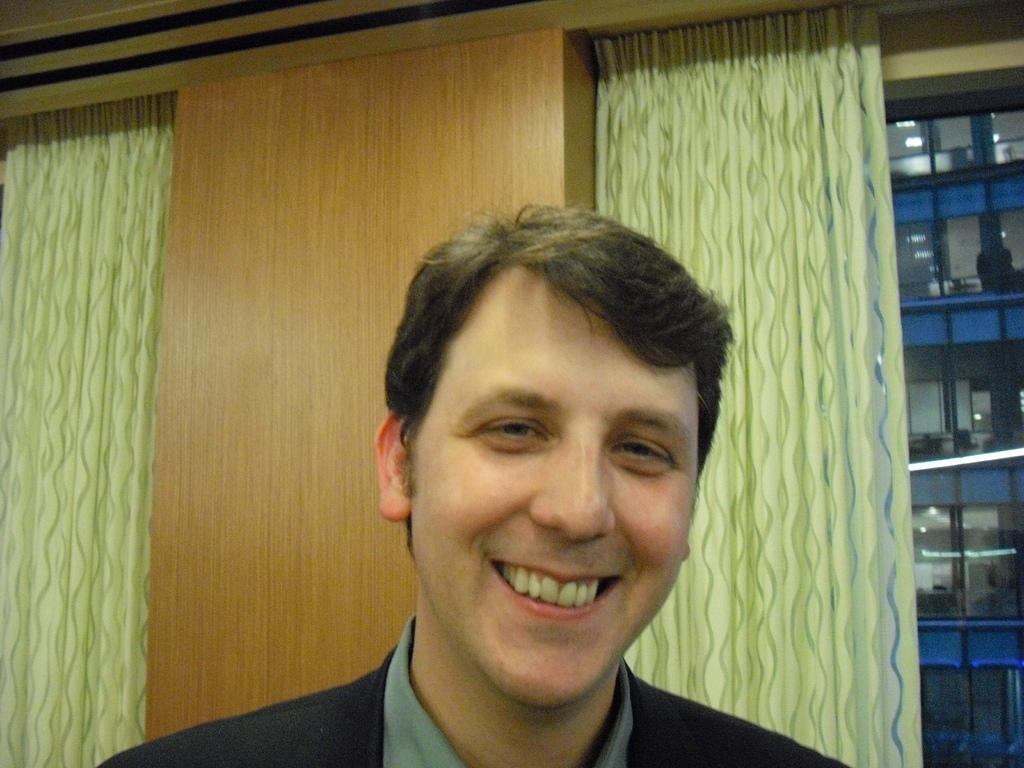What is the person in the image wearing? The person is wearing a black and grey color dress. What is the facial expression of the person in the image? The person is smiling. What can be seen in the background of the image? There are curtains and a wooden wall visible in the background. What is located to the right of the image? There is a rack to the right of the image. What type of harbor can be seen in the background of the image? There is no harbor visible in the background of the image; it features curtains and a wooden wall. What industry is represented by the person in the image? The image does not depict any specific industry; it simply shows a person wearing a dress and smiling. 